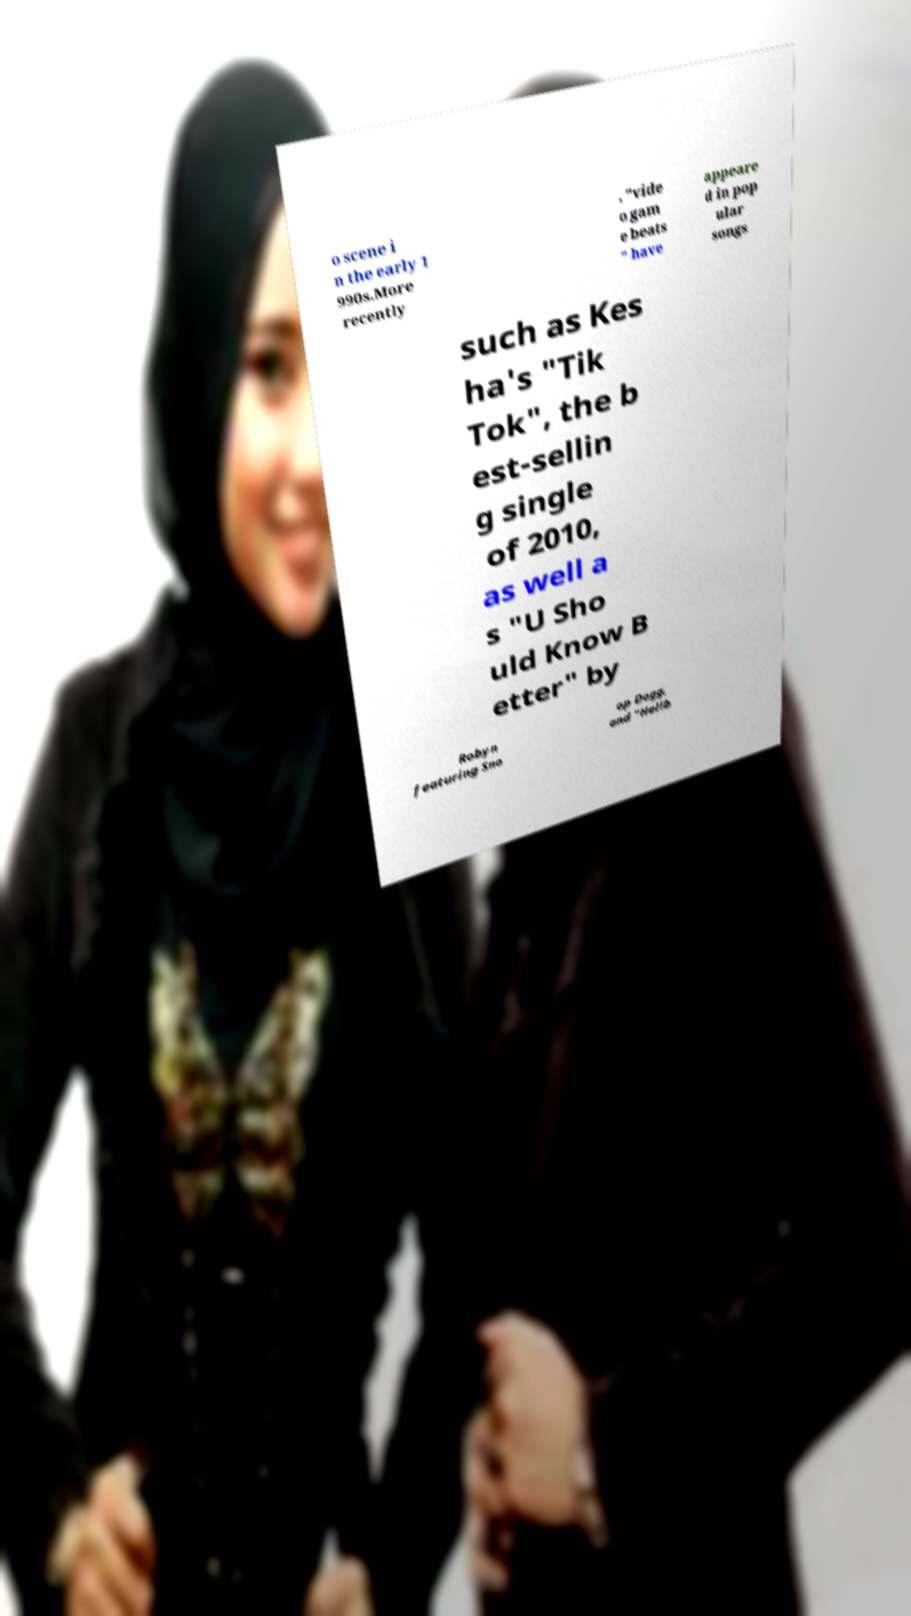For documentation purposes, I need the text within this image transcribed. Could you provide that? o scene i n the early 1 990s.More recently , "vide o gam e beats " have appeare d in pop ular songs such as Kes ha's "Tik Tok", the b est-sellin g single of 2010, as well a s "U Sho uld Know B etter" by Robyn featuring Sno op Dogg, and "Hellb 